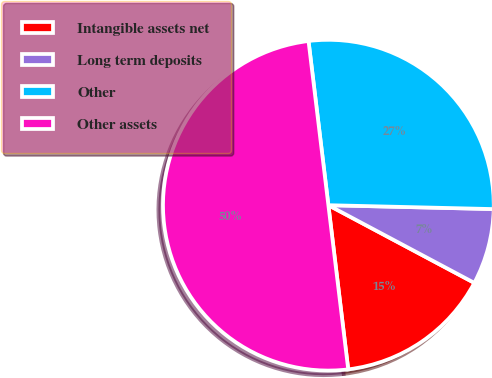Convert chart. <chart><loc_0><loc_0><loc_500><loc_500><pie_chart><fcel>Intangible assets net<fcel>Long term deposits<fcel>Other<fcel>Other assets<nl><fcel>15.3%<fcel>7.41%<fcel>27.29%<fcel>50.0%<nl></chart> 